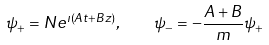Convert formula to latex. <formula><loc_0><loc_0><loc_500><loc_500>\psi _ { + } = N e ^ { \imath ( A t + B z ) } , \quad \psi _ { - } = - \frac { A + B } { m } \psi _ { + }</formula> 